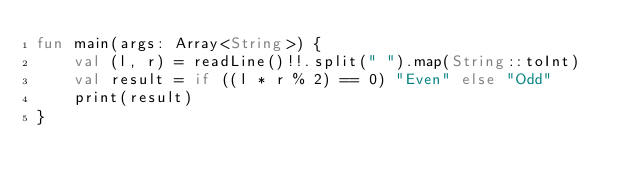Convert code to text. <code><loc_0><loc_0><loc_500><loc_500><_Kotlin_>fun main(args: Array<String>) {
    val (l, r) = readLine()!!.split(" ").map(String::toInt)
    val result = if ((l * r % 2) == 0) "Even" else "Odd"
    print(result)
}</code> 